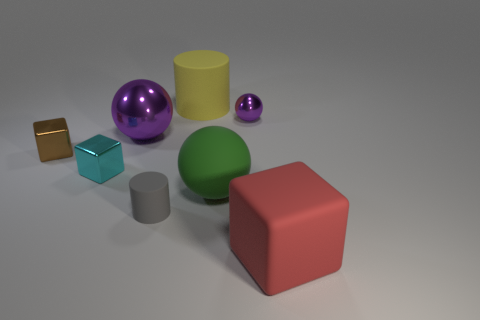Is there a green object on the left side of the cylinder behind the large green rubber object? There is no object on the left side of the cylinder behind the large green rubber object. The space in that specific area is clear, with no additional items present. 